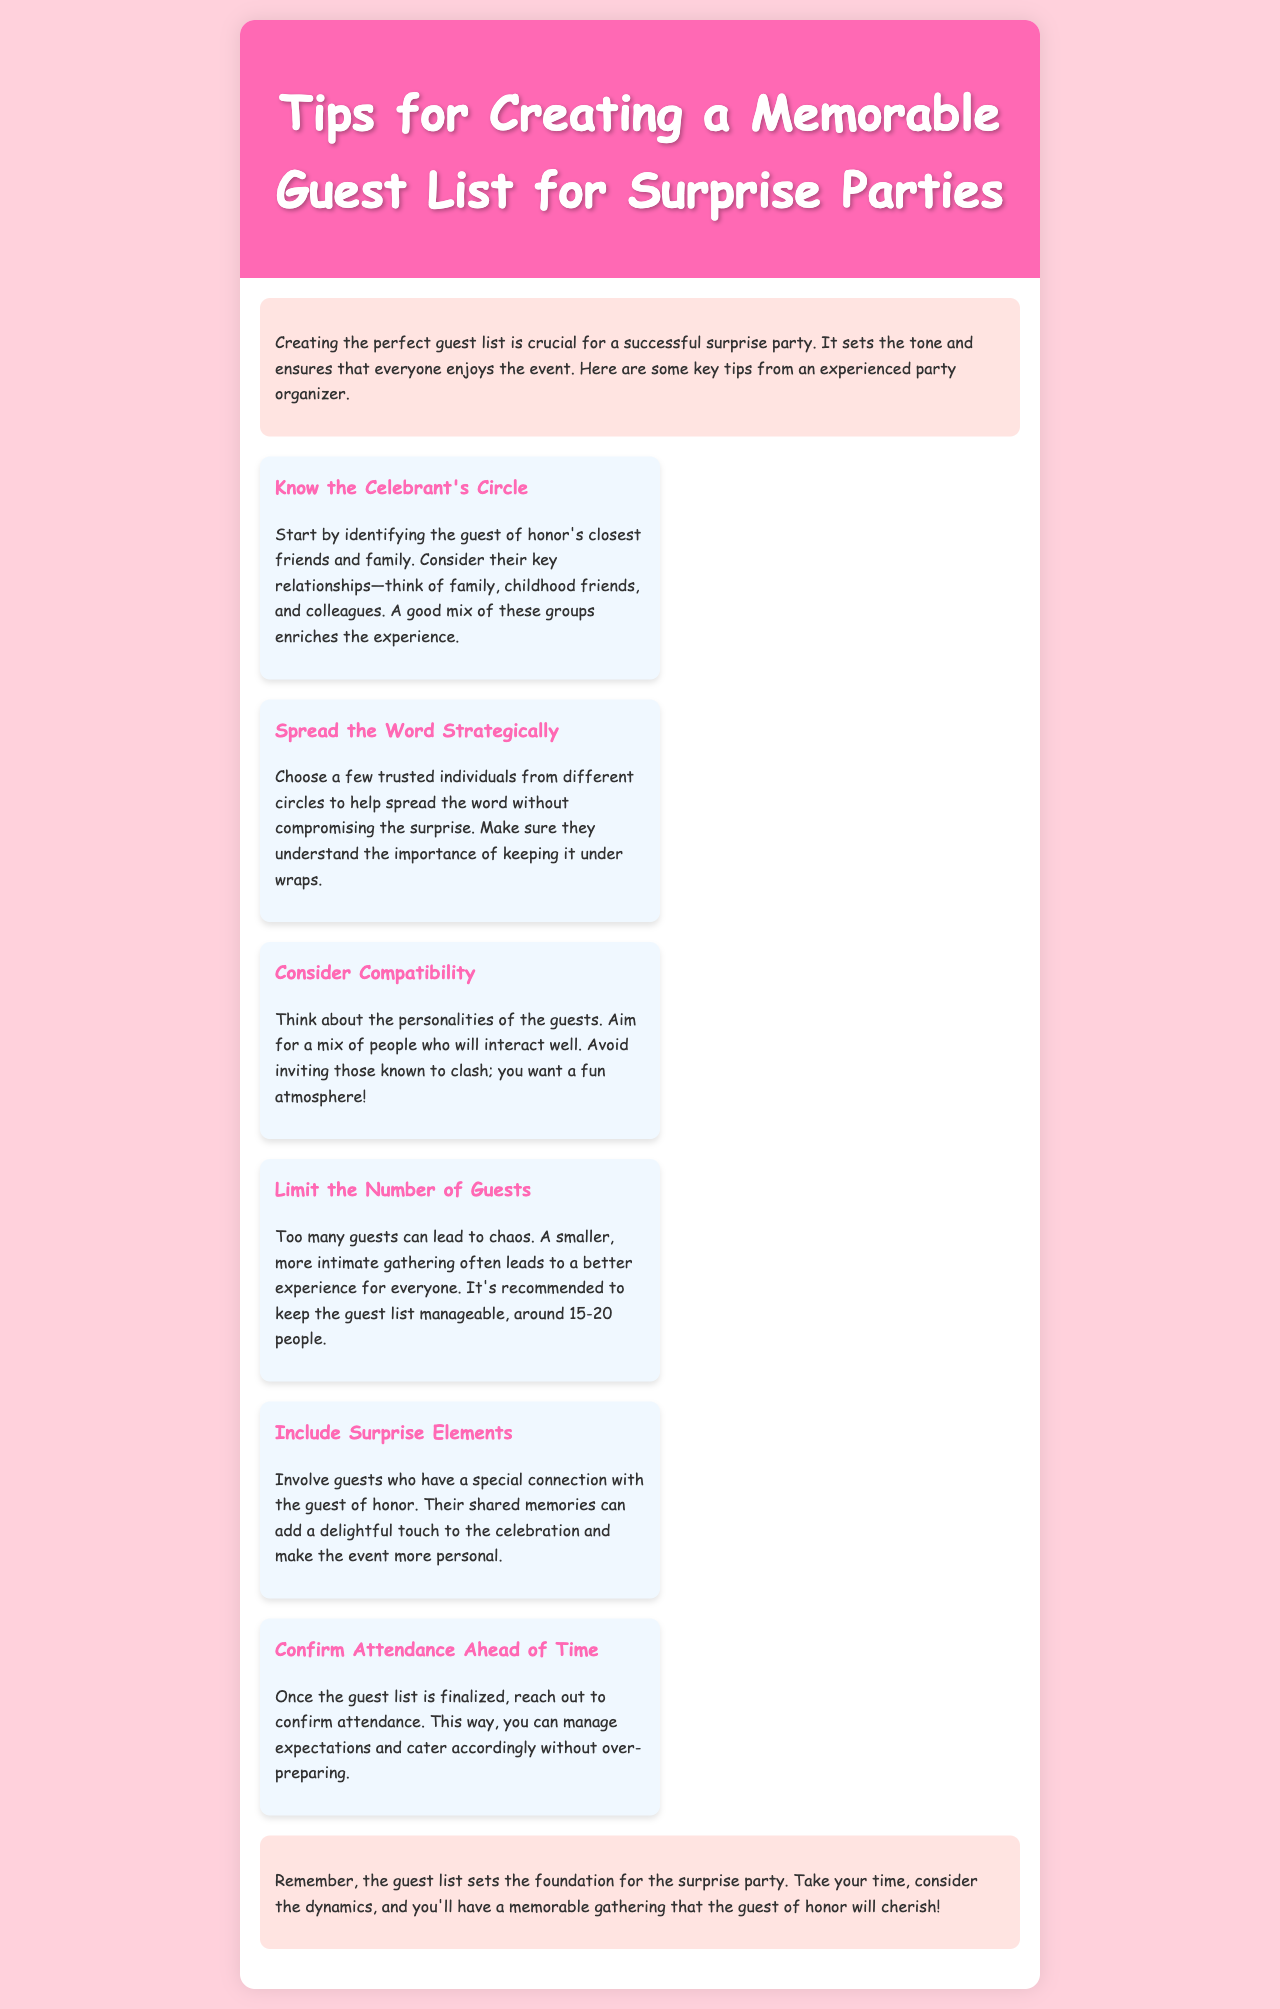what is the title of the brochure? The title is prominently displayed at the top of the document, providing the main topic of discussion.
Answer: Tips for Creating a Memorable Guest List for Surprise Parties how many tips are listed in the document? The document contains a section with multiple tips for creating a guest list, counting them gives the total number.
Answer: 6 what is a recommended number of guests for the party? The document suggests a specific range for the guest list size, which is defined to enhance the experience.
Answer: around 15-20 people which section discusses managing guest dynamics? The document includes a tip that focuses on the interactions and relationships among guests, crucial for a successful gathering.
Answer: Consider Compatibility who should help spread the word according to the tips? The brochure advises involving specific types of individuals to assist in communication without ruining the surprise.
Answer: trusted individuals what is emphasized as important in the introduction? The introduction mentions a key element that contributes to the success of the surprise party, setting the stage for the entire event.
Answer: perfect guest list 